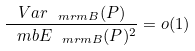<formula> <loc_0><loc_0><loc_500><loc_500>\frac { V a r _ { \ m r m { B } } ( P ) } { \ m b { E } _ { \ m r m { B } } ( P ) ^ { 2 } } = o ( 1 )</formula> 